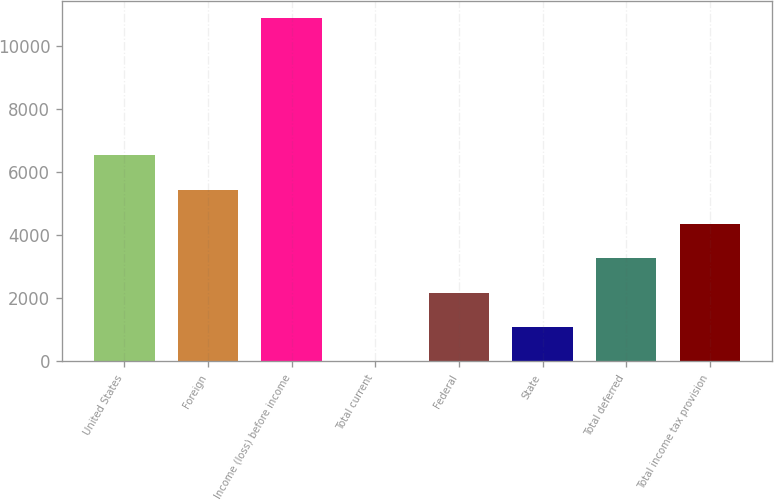Convert chart. <chart><loc_0><loc_0><loc_500><loc_500><bar_chart><fcel>United States<fcel>Foreign<fcel>Income (loss) before income<fcel>Total current<fcel>Federal<fcel>State<fcel>Total deferred<fcel>Total income tax provision<nl><fcel>6522<fcel>5433<fcel>10863<fcel>3<fcel>2175<fcel>1089<fcel>3261<fcel>4347<nl></chart> 